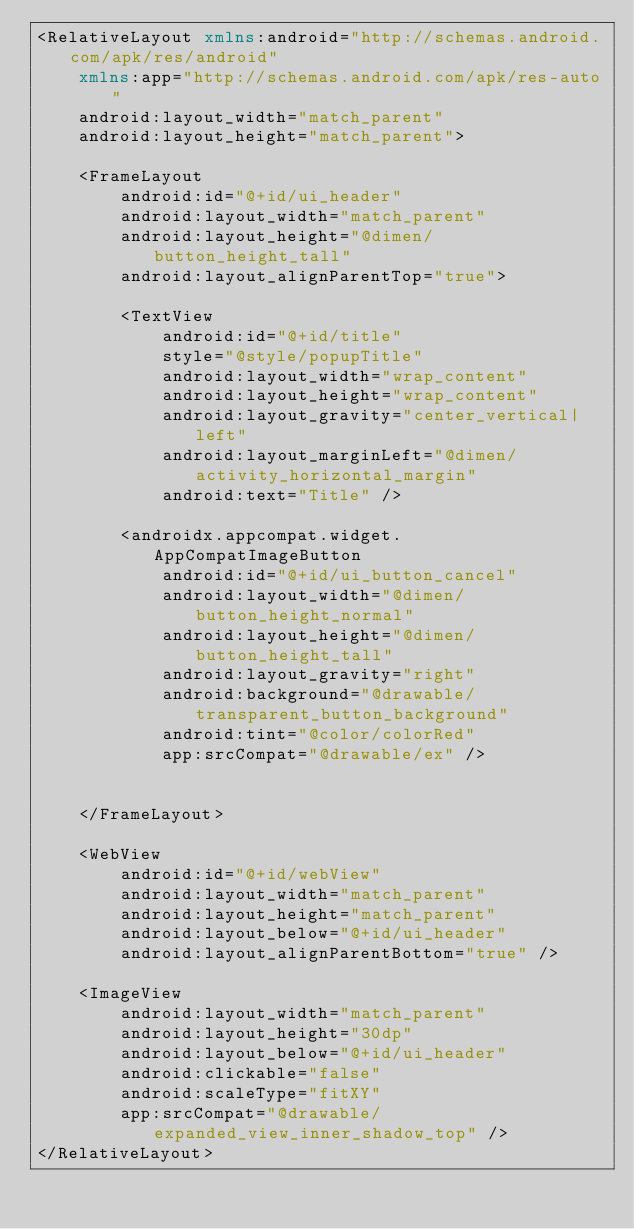Convert code to text. <code><loc_0><loc_0><loc_500><loc_500><_XML_><RelativeLayout xmlns:android="http://schemas.android.com/apk/res/android"
    xmlns:app="http://schemas.android.com/apk/res-auto"
    android:layout_width="match_parent"
    android:layout_height="match_parent">

    <FrameLayout
        android:id="@+id/ui_header"
        android:layout_width="match_parent"
        android:layout_height="@dimen/button_height_tall"
        android:layout_alignParentTop="true">

        <TextView
            android:id="@+id/title"
            style="@style/popupTitle"
            android:layout_width="wrap_content"
            android:layout_height="wrap_content"
            android:layout_gravity="center_vertical|left"
            android:layout_marginLeft="@dimen/activity_horizontal_margin"
            android:text="Title" />

        <androidx.appcompat.widget.AppCompatImageButton
            android:id="@+id/ui_button_cancel"
            android:layout_width="@dimen/button_height_normal"
            android:layout_height="@dimen/button_height_tall"
            android:layout_gravity="right"
            android:background="@drawable/transparent_button_background"
            android:tint="@color/colorRed"
            app:srcCompat="@drawable/ex" />


    </FrameLayout>

    <WebView
        android:id="@+id/webView"
        android:layout_width="match_parent"
        android:layout_height="match_parent"
        android:layout_below="@+id/ui_header"
        android:layout_alignParentBottom="true" />

    <ImageView
        android:layout_width="match_parent"
        android:layout_height="30dp"
        android:layout_below="@+id/ui_header"
        android:clickable="false"
        android:scaleType="fitXY"
        app:srcCompat="@drawable/expanded_view_inner_shadow_top" />
</RelativeLayout></code> 